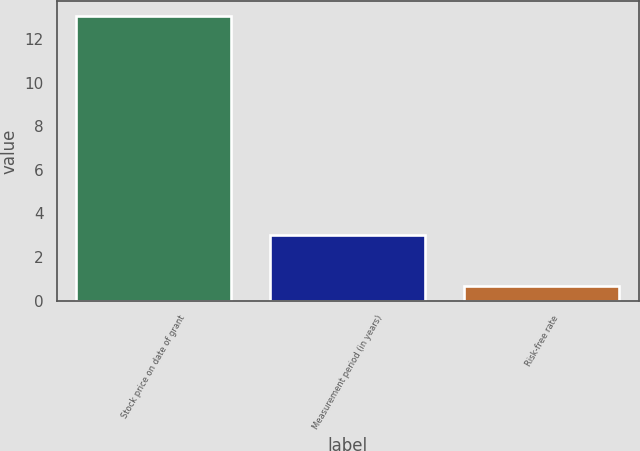Convert chart. <chart><loc_0><loc_0><loc_500><loc_500><bar_chart><fcel>Stock price on date of grant<fcel>Measurement period (in years)<fcel>Risk-free rate<nl><fcel>13.08<fcel>3<fcel>0.66<nl></chart> 